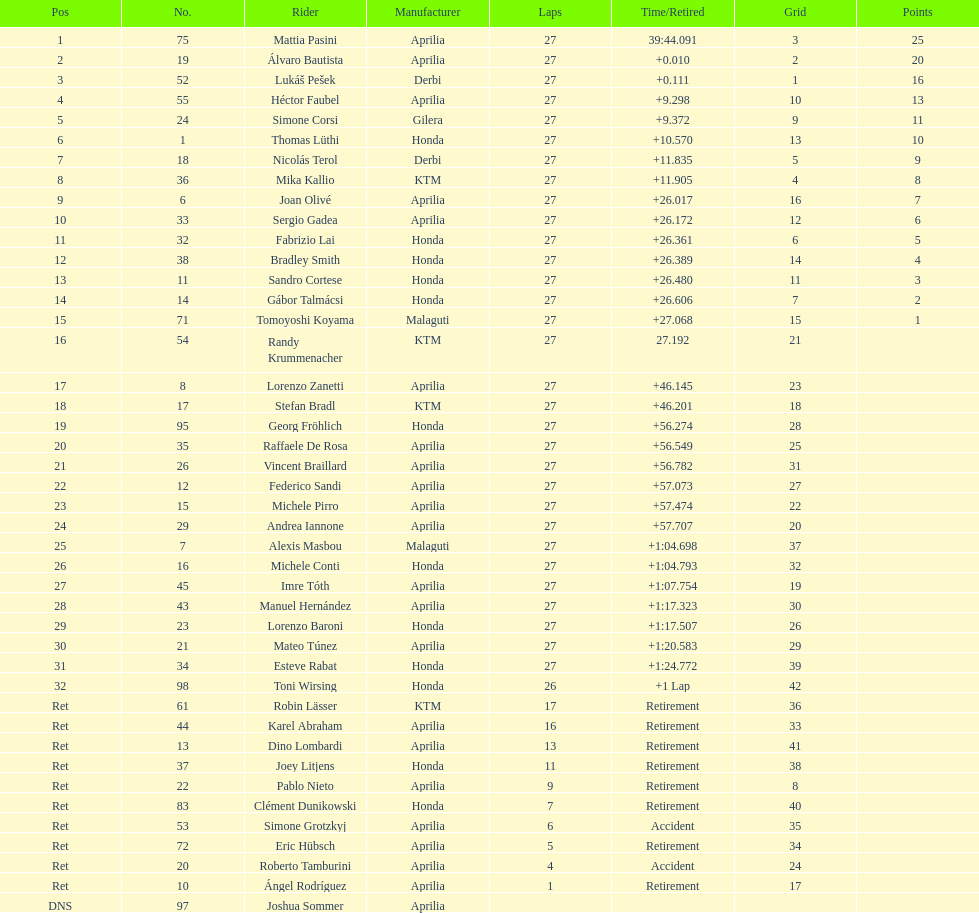I'm looking to parse the entire table for insights. Could you assist me with that? {'header': ['Pos', 'No.', 'Rider', 'Manufacturer', 'Laps', 'Time/Retired', 'Grid', 'Points'], 'rows': [['1', '75', 'Mattia Pasini', 'Aprilia', '27', '39:44.091', '3', '25'], ['2', '19', 'Álvaro Bautista', 'Aprilia', '27', '+0.010', '2', '20'], ['3', '52', 'Lukáš Pešek', 'Derbi', '27', '+0.111', '1', '16'], ['4', '55', 'Héctor Faubel', 'Aprilia', '27', '+9.298', '10', '13'], ['5', '24', 'Simone Corsi', 'Gilera', '27', '+9.372', '9', '11'], ['6', '1', 'Thomas Lüthi', 'Honda', '27', '+10.570', '13', '10'], ['7', '18', 'Nicolás Terol', 'Derbi', '27', '+11.835', '5', '9'], ['8', '36', 'Mika Kallio', 'KTM', '27', '+11.905', '4', '8'], ['9', '6', 'Joan Olivé', 'Aprilia', '27', '+26.017', '16', '7'], ['10', '33', 'Sergio Gadea', 'Aprilia', '27', '+26.172', '12', '6'], ['11', '32', 'Fabrizio Lai', 'Honda', '27', '+26.361', '6', '5'], ['12', '38', 'Bradley Smith', 'Honda', '27', '+26.389', '14', '4'], ['13', '11', 'Sandro Cortese', 'Honda', '27', '+26.480', '11', '3'], ['14', '14', 'Gábor Talmácsi', 'Honda', '27', '+26.606', '7', '2'], ['15', '71', 'Tomoyoshi Koyama', 'Malaguti', '27', '+27.068', '15', '1'], ['16', '54', 'Randy Krummenacher', 'KTM', '27', '27.192', '21', ''], ['17', '8', 'Lorenzo Zanetti', 'Aprilia', '27', '+46.145', '23', ''], ['18', '17', 'Stefan Bradl', 'KTM', '27', '+46.201', '18', ''], ['19', '95', 'Georg Fröhlich', 'Honda', '27', '+56.274', '28', ''], ['20', '35', 'Raffaele De Rosa', 'Aprilia', '27', '+56.549', '25', ''], ['21', '26', 'Vincent Braillard', 'Aprilia', '27', '+56.782', '31', ''], ['22', '12', 'Federico Sandi', 'Aprilia', '27', '+57.073', '27', ''], ['23', '15', 'Michele Pirro', 'Aprilia', '27', '+57.474', '22', ''], ['24', '29', 'Andrea Iannone', 'Aprilia', '27', '+57.707', '20', ''], ['25', '7', 'Alexis Masbou', 'Malaguti', '27', '+1:04.698', '37', ''], ['26', '16', 'Michele Conti', 'Honda', '27', '+1:04.793', '32', ''], ['27', '45', 'Imre Tóth', 'Aprilia', '27', '+1:07.754', '19', ''], ['28', '43', 'Manuel Hernández', 'Aprilia', '27', '+1:17.323', '30', ''], ['29', '23', 'Lorenzo Baroni', 'Honda', '27', '+1:17.507', '26', ''], ['30', '21', 'Mateo Túnez', 'Aprilia', '27', '+1:20.583', '29', ''], ['31', '34', 'Esteve Rabat', 'Honda', '27', '+1:24.772', '39', ''], ['32', '98', 'Toni Wirsing', 'Honda', '26', '+1 Lap', '42', ''], ['Ret', '61', 'Robin Lässer', 'KTM', '17', 'Retirement', '36', ''], ['Ret', '44', 'Karel Abraham', 'Aprilia', '16', 'Retirement', '33', ''], ['Ret', '13', 'Dino Lombardi', 'Aprilia', '13', 'Retirement', '41', ''], ['Ret', '37', 'Joey Litjens', 'Honda', '11', 'Retirement', '38', ''], ['Ret', '22', 'Pablo Nieto', 'Aprilia', '9', 'Retirement', '8', ''], ['Ret', '83', 'Clément Dunikowski', 'Honda', '7', 'Retirement', '40', ''], ['Ret', '53', 'Simone Grotzkyj', 'Aprilia', '6', 'Accident', '35', ''], ['Ret', '72', 'Eric Hübsch', 'Aprilia', '5', 'Retirement', '34', ''], ['Ret', '20', 'Roberto Tamburini', 'Aprilia', '4', 'Accident', '24', ''], ['Ret', '10', 'Ángel Rodríguez', 'Aprilia', '1', 'Retirement', '17', ''], ['DNS', '97', 'Joshua Sommer', 'Aprilia', '', '', '', '']]} State a racing contestant who amassed 20 or more points. Mattia Pasini. 